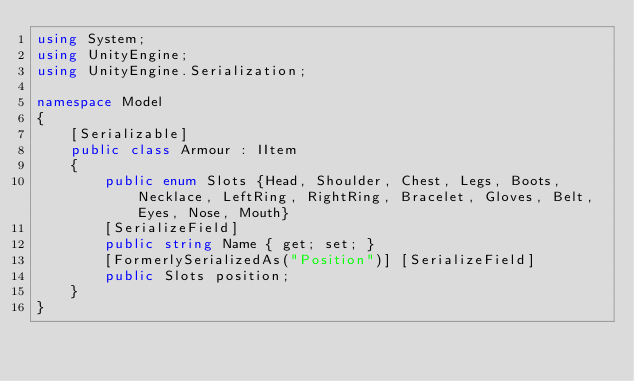Convert code to text. <code><loc_0><loc_0><loc_500><loc_500><_C#_>using System;
using UnityEngine;
using UnityEngine.Serialization;

namespace Model
{
    [Serializable]
    public class Armour : IItem
    {
        public enum Slots {Head, Shoulder, Chest, Legs, Boots, Necklace, LeftRing, RightRing, Bracelet, Gloves, Belt, Eyes, Nose, Mouth}
        [SerializeField]
        public string Name { get; set; }
        [FormerlySerializedAs("Position")] [SerializeField]
        public Slots position;
    }
}</code> 